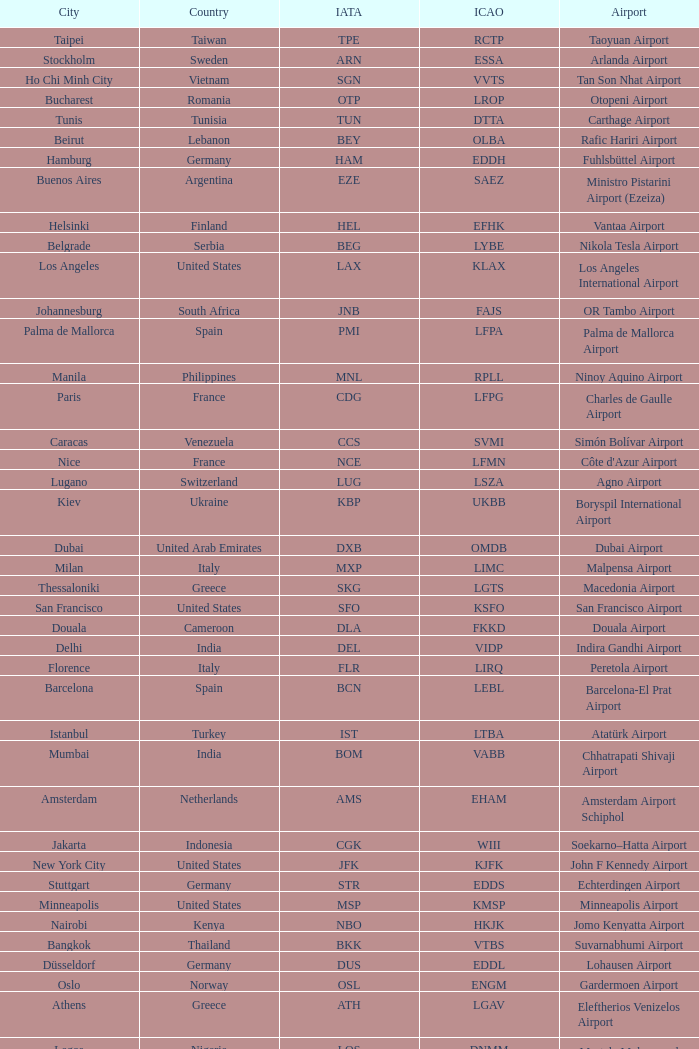What is the IATA for Ringway Airport in the United Kingdom? MAN. 